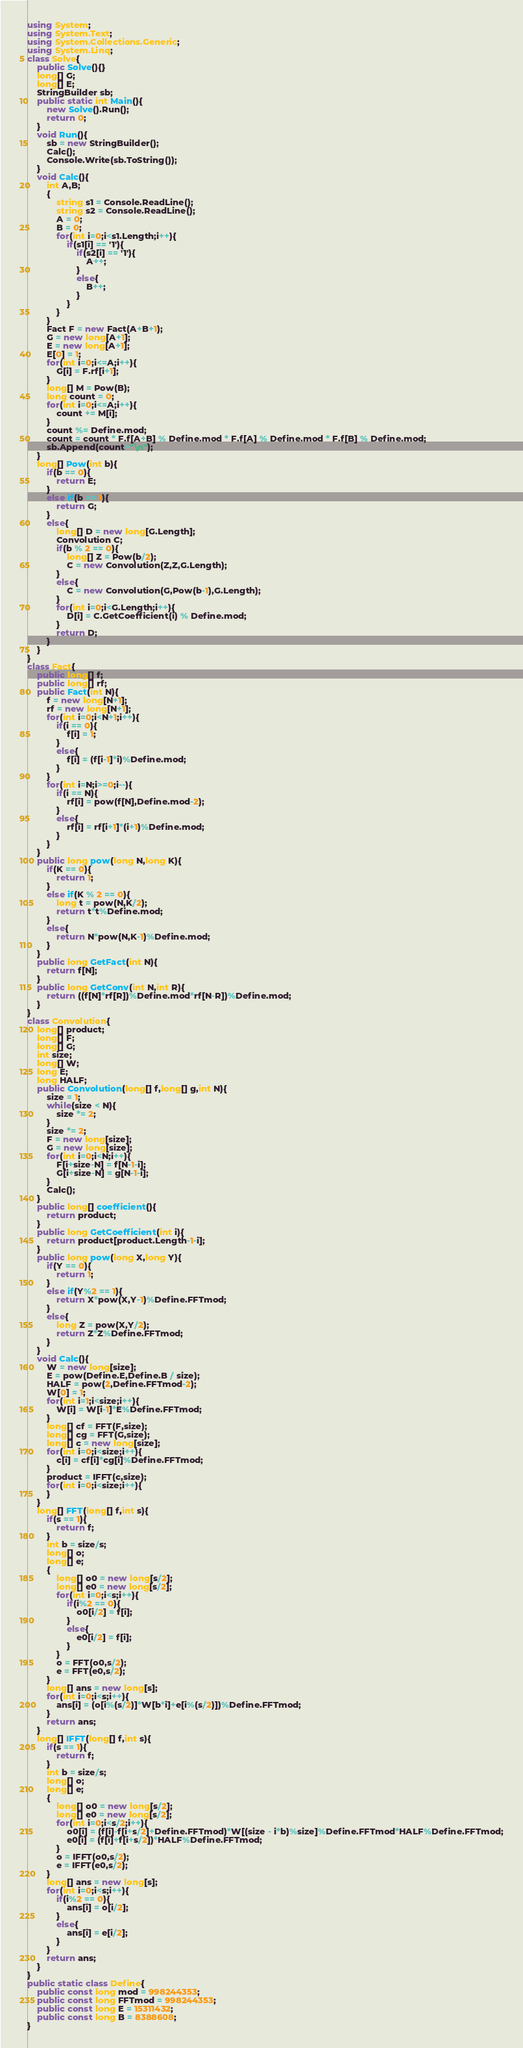Convert code to text. <code><loc_0><loc_0><loc_500><loc_500><_C#_>using System;
using System.Text;
using System.Collections.Generic;
using System.Linq;
class Solve{
    public Solve(){}
    long[] G;
    long[] E;
    StringBuilder sb;
    public static int Main(){
        new Solve().Run();
        return 0;
    }
    void Run(){
        sb = new StringBuilder();
        Calc();
        Console.Write(sb.ToString());
    }
    void Calc(){
        int A,B;
        {
            string s1 = Console.ReadLine();
            string s2 = Console.ReadLine();
            A = 0;
            B = 0;
            for(int i=0;i<s1.Length;i++){
                if(s1[i] == '1'){
                    if(s2[i] == '1'){
                        A++;
                    }
                    else{
                        B++;
                    }
                }
            }
        }
        Fact F = new Fact(A+B+1);
        G = new long[A+1];
        E = new long[A+1];
        E[0] = 1;
        for(int i=0;i<=A;i++){
            G[i] = F.rf[i+1];
        }
        long[] M = Pow(B);
        long count = 0;
        for(int i=0;i<=A;i++){
            count += M[i];
        }
        count %= Define.mod;
        count = count * F.f[A+B] % Define.mod * F.f[A] % Define.mod * F.f[B] % Define.mod;
        sb.Append(count+"\n");
    }
    long[] Pow(int b){
        if(b == 0){
            return E;
        }
        else if(b == 1){
            return G;
        }
        else{
            long[] D = new long[G.Length];
            Convolution C;
            if(b % 2 == 0){
                long[] Z = Pow(b/2);
                C = new Convolution(Z,Z,G.Length);
            }
            else{
                C = new Convolution(G,Pow(b-1),G.Length);
            }
            for(int i=0;i<G.Length;i++){
                D[i] = C.GetCoefficient(i) % Define.mod;
            }
            return D;
        }
    }
}
class Fact{
    public long[] f;
    public long[] rf;
    public Fact(int N){
        f = new long[N+1];
        rf = new long[N+1];
        for(int i=0;i<N+1;i++){
            if(i == 0){
                f[i] = 1;
            }
            else{
                f[i] = (f[i-1]*i)%Define.mod;
            }
        }
        for(int i=N;i>=0;i--){
            if(i == N){
                rf[i] = pow(f[N],Define.mod-2);
            }
            else{
                rf[i] = rf[i+1]*(i+1)%Define.mod;
            }
        }
    }
    public long pow(long N,long K){
        if(K == 0){
            return 1;
        }
        else if(K % 2 == 0){
            long t = pow(N,K/2);
            return t*t%Define.mod;
        }
        else{
            return N*pow(N,K-1)%Define.mod;
        }
    }
    public long GetFact(int N){
        return f[N];
    }
    public long GetConv(int N,int R){
        return ((f[N]*rf[R])%Define.mod*rf[N-R])%Define.mod;
    }
}
class Convolution{
    long[] product;
    long[] F;
    long[] G;
    int size;
    long[] W;
    long E;
    long HALF;
    public Convolution(long[] f,long[] g,int N){
        size = 1;
        while(size < N){
            size *= 2;
        }
        size *= 2;
        F = new long[size];
        G = new long[size];
        for(int i=0;i<N;i++){
            F[i+size-N] = f[N-1-i];
            G[i+size-N] = g[N-1-i];
        }
        Calc();
    }
    public long[] coefficient(){
        return product;
    }
    public long GetCoefficient(int i){
        return product[product.Length-1-i];
    }
    public long pow(long X,long Y){
        if(Y == 0){
            return 1;
        }
        else if(Y%2 == 1){
            return X*pow(X,Y-1)%Define.FFTmod;
        }
        else{
            long Z = pow(X,Y/2);
            return Z*Z%Define.FFTmod;
        }
    }
    void Calc(){
        W = new long[size];
        E = pow(Define.E,Define.B / size);
        HALF = pow(2,Define.FFTmod-2);
        W[0] = 1;
        for(int i=1;i<size;i++){
            W[i] = W[i-1]*E%Define.FFTmod;
        }
        long[] cf = FFT(F,size);
        long[] cg = FFT(G,size);
        long[] c = new long[size];
        for(int i=0;i<size;i++){
            c[i] = cf[i]*cg[i]%Define.FFTmod;
        }
        product = IFFT(c,size);
        for(int i=0;i<size;i++){
        }
    }
    long[] FFT(long[] f,int s){
        if(s == 1){
            return f;
        }
        int b = size/s;
        long[] o;
        long[] e;
        {
            long[] o0 = new long[s/2];
            long[] e0 = new long[s/2];
            for(int i=0;i<s;i++){
                if(i%2 == 0){
                    o0[i/2] = f[i];
                }
                else{
                    e0[i/2] = f[i];
                }
            }
            o = FFT(o0,s/2);
            e = FFT(e0,s/2);
        }
        long[] ans = new long[s];
        for(int i=0;i<s;i++){
            ans[i] = (o[i%(s/2)]*W[b*i]+e[i%(s/2)])%Define.FFTmod;
        }
        return ans;
    }
    long[] IFFT(long[] f,int s){
        if(s == 1){
            return f;
        }
        int b = size/s;
        long[] o;
        long[] e;
        {
            long[] o0 = new long[s/2];
            long[] e0 = new long[s/2];
            for(int i=0;i<s/2;i++){
                o0[i] = (f[i]-f[i+s/2]+Define.FFTmod)*W[(size - i*b)%size]%Define.FFTmod*HALF%Define.FFTmod;
                e0[i] = (f[i]+f[i+s/2])*HALF%Define.FFTmod;
            }
            o = IFFT(o0,s/2);
            e = IFFT(e0,s/2);
        }
        long[] ans = new long[s];
        for(int i=0;i<s;i++){
            if(i%2 == 0){
                ans[i] = o[i/2];
            }
            else{
                ans[i] = e[i/2];
            }
        }
        return ans;
    }
}
public static class Define{
    public const long mod = 998244353;
    public const long FFTmod = 998244353;
    public const long E = 15311432;
    public const long B = 8388608;
}</code> 